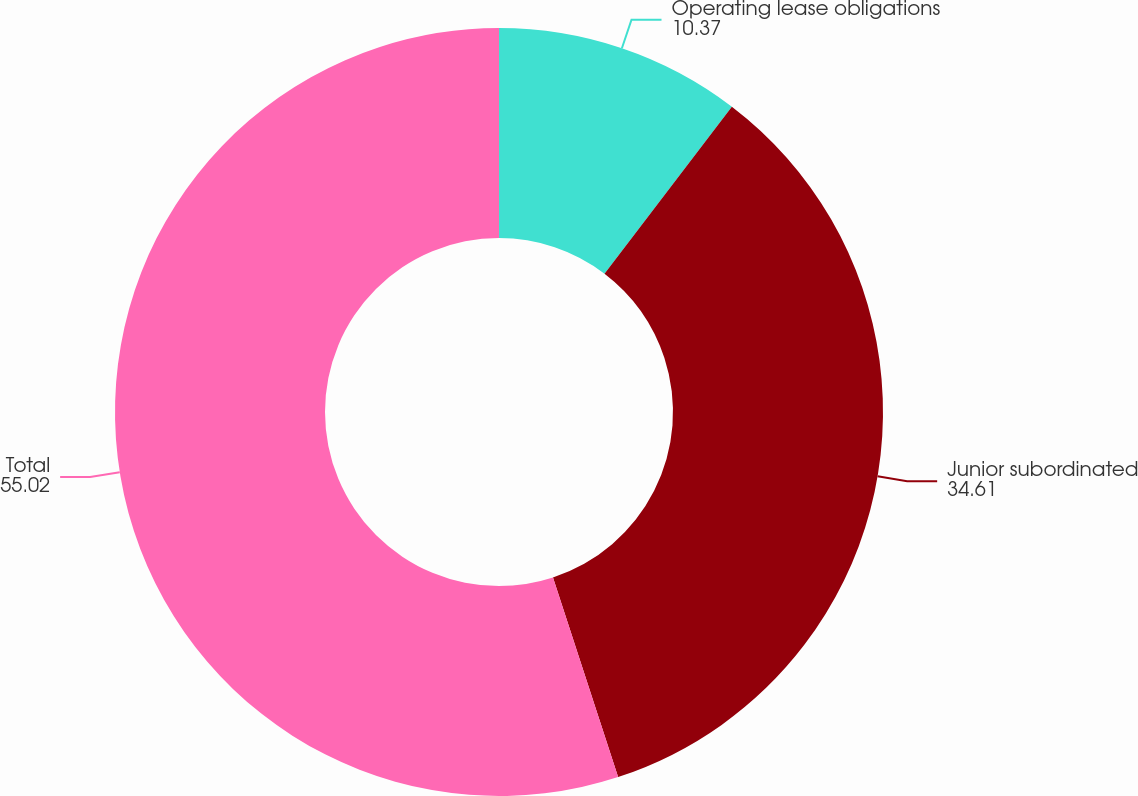<chart> <loc_0><loc_0><loc_500><loc_500><pie_chart><fcel>Operating lease obligations<fcel>Junior subordinated<fcel>Total<nl><fcel>10.37%<fcel>34.61%<fcel>55.02%<nl></chart> 